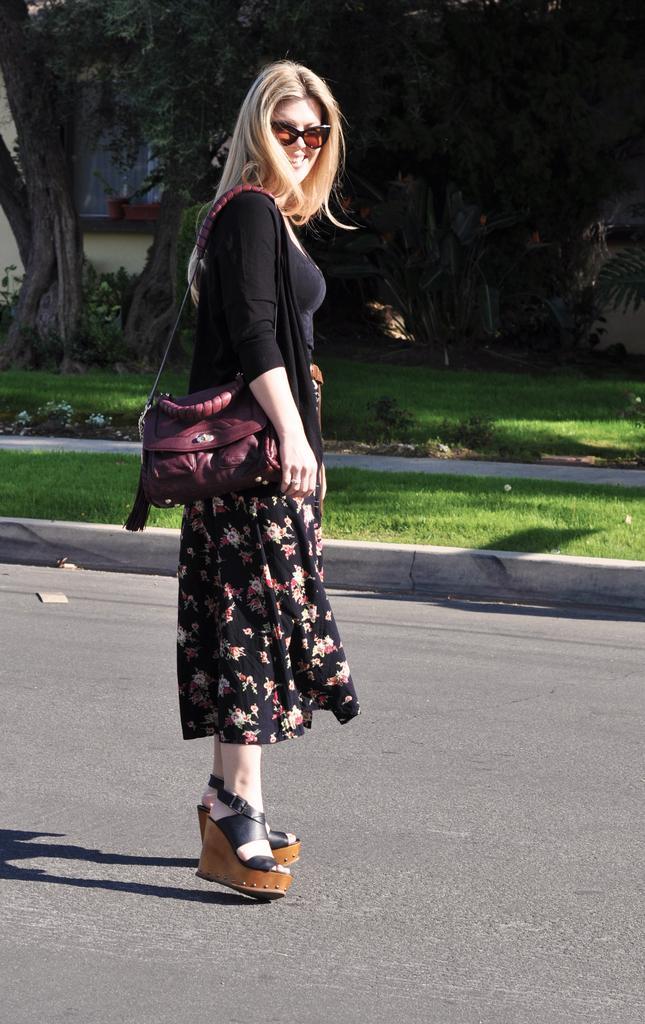Could you give a brief overview of what you see in this image? In this picture we can see a woman standing on the road and she is wearing bag, side we can see wall, trees and grass. 